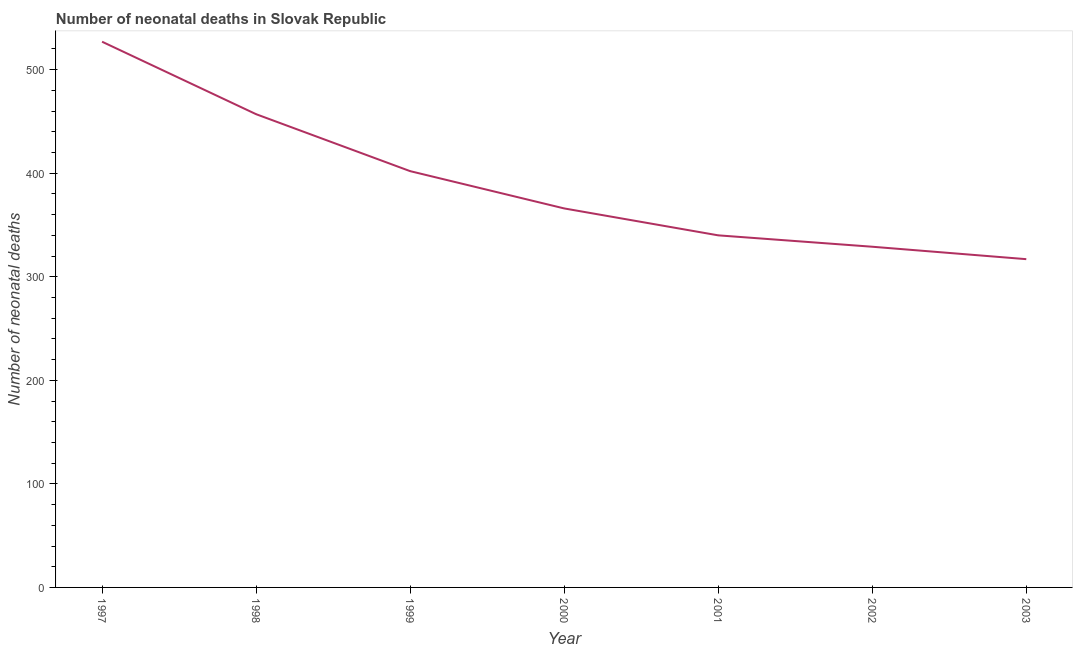What is the number of neonatal deaths in 1998?
Offer a terse response. 457. Across all years, what is the maximum number of neonatal deaths?
Provide a short and direct response. 527. Across all years, what is the minimum number of neonatal deaths?
Provide a succinct answer. 317. What is the sum of the number of neonatal deaths?
Your answer should be very brief. 2738. What is the difference between the number of neonatal deaths in 1999 and 2000?
Give a very brief answer. 36. What is the average number of neonatal deaths per year?
Keep it short and to the point. 391.14. What is the median number of neonatal deaths?
Ensure brevity in your answer.  366. Do a majority of the years between 2000 and 2002 (inclusive) have number of neonatal deaths greater than 420 ?
Your answer should be very brief. No. What is the ratio of the number of neonatal deaths in 1997 to that in 2000?
Make the answer very short. 1.44. What is the difference between the highest and the second highest number of neonatal deaths?
Give a very brief answer. 70. Is the sum of the number of neonatal deaths in 2000 and 2001 greater than the maximum number of neonatal deaths across all years?
Ensure brevity in your answer.  Yes. What is the difference between the highest and the lowest number of neonatal deaths?
Your answer should be very brief. 210. Does the number of neonatal deaths monotonically increase over the years?
Keep it short and to the point. No. How many lines are there?
Keep it short and to the point. 1. What is the difference between two consecutive major ticks on the Y-axis?
Make the answer very short. 100. Does the graph contain any zero values?
Provide a succinct answer. No. What is the title of the graph?
Provide a short and direct response. Number of neonatal deaths in Slovak Republic. What is the label or title of the X-axis?
Your answer should be very brief. Year. What is the label or title of the Y-axis?
Your answer should be compact. Number of neonatal deaths. What is the Number of neonatal deaths in 1997?
Your answer should be very brief. 527. What is the Number of neonatal deaths of 1998?
Offer a very short reply. 457. What is the Number of neonatal deaths of 1999?
Provide a succinct answer. 402. What is the Number of neonatal deaths of 2000?
Offer a very short reply. 366. What is the Number of neonatal deaths of 2001?
Give a very brief answer. 340. What is the Number of neonatal deaths of 2002?
Offer a very short reply. 329. What is the Number of neonatal deaths of 2003?
Your response must be concise. 317. What is the difference between the Number of neonatal deaths in 1997 and 1998?
Ensure brevity in your answer.  70. What is the difference between the Number of neonatal deaths in 1997 and 1999?
Your response must be concise. 125. What is the difference between the Number of neonatal deaths in 1997 and 2000?
Give a very brief answer. 161. What is the difference between the Number of neonatal deaths in 1997 and 2001?
Ensure brevity in your answer.  187. What is the difference between the Number of neonatal deaths in 1997 and 2002?
Ensure brevity in your answer.  198. What is the difference between the Number of neonatal deaths in 1997 and 2003?
Provide a short and direct response. 210. What is the difference between the Number of neonatal deaths in 1998 and 1999?
Your answer should be compact. 55. What is the difference between the Number of neonatal deaths in 1998 and 2000?
Ensure brevity in your answer.  91. What is the difference between the Number of neonatal deaths in 1998 and 2001?
Your response must be concise. 117. What is the difference between the Number of neonatal deaths in 1998 and 2002?
Your response must be concise. 128. What is the difference between the Number of neonatal deaths in 1998 and 2003?
Provide a succinct answer. 140. What is the difference between the Number of neonatal deaths in 1999 and 2000?
Make the answer very short. 36. What is the difference between the Number of neonatal deaths in 1999 and 2003?
Provide a short and direct response. 85. What is the difference between the Number of neonatal deaths in 2000 and 2001?
Offer a terse response. 26. What is the ratio of the Number of neonatal deaths in 1997 to that in 1998?
Offer a very short reply. 1.15. What is the ratio of the Number of neonatal deaths in 1997 to that in 1999?
Keep it short and to the point. 1.31. What is the ratio of the Number of neonatal deaths in 1997 to that in 2000?
Make the answer very short. 1.44. What is the ratio of the Number of neonatal deaths in 1997 to that in 2001?
Provide a succinct answer. 1.55. What is the ratio of the Number of neonatal deaths in 1997 to that in 2002?
Offer a terse response. 1.6. What is the ratio of the Number of neonatal deaths in 1997 to that in 2003?
Keep it short and to the point. 1.66. What is the ratio of the Number of neonatal deaths in 1998 to that in 1999?
Provide a succinct answer. 1.14. What is the ratio of the Number of neonatal deaths in 1998 to that in 2000?
Offer a very short reply. 1.25. What is the ratio of the Number of neonatal deaths in 1998 to that in 2001?
Your answer should be compact. 1.34. What is the ratio of the Number of neonatal deaths in 1998 to that in 2002?
Make the answer very short. 1.39. What is the ratio of the Number of neonatal deaths in 1998 to that in 2003?
Offer a terse response. 1.44. What is the ratio of the Number of neonatal deaths in 1999 to that in 2000?
Offer a terse response. 1.1. What is the ratio of the Number of neonatal deaths in 1999 to that in 2001?
Make the answer very short. 1.18. What is the ratio of the Number of neonatal deaths in 1999 to that in 2002?
Offer a very short reply. 1.22. What is the ratio of the Number of neonatal deaths in 1999 to that in 2003?
Offer a very short reply. 1.27. What is the ratio of the Number of neonatal deaths in 2000 to that in 2001?
Your answer should be compact. 1.08. What is the ratio of the Number of neonatal deaths in 2000 to that in 2002?
Keep it short and to the point. 1.11. What is the ratio of the Number of neonatal deaths in 2000 to that in 2003?
Ensure brevity in your answer.  1.16. What is the ratio of the Number of neonatal deaths in 2001 to that in 2002?
Keep it short and to the point. 1.03. What is the ratio of the Number of neonatal deaths in 2001 to that in 2003?
Your response must be concise. 1.07. What is the ratio of the Number of neonatal deaths in 2002 to that in 2003?
Your response must be concise. 1.04. 